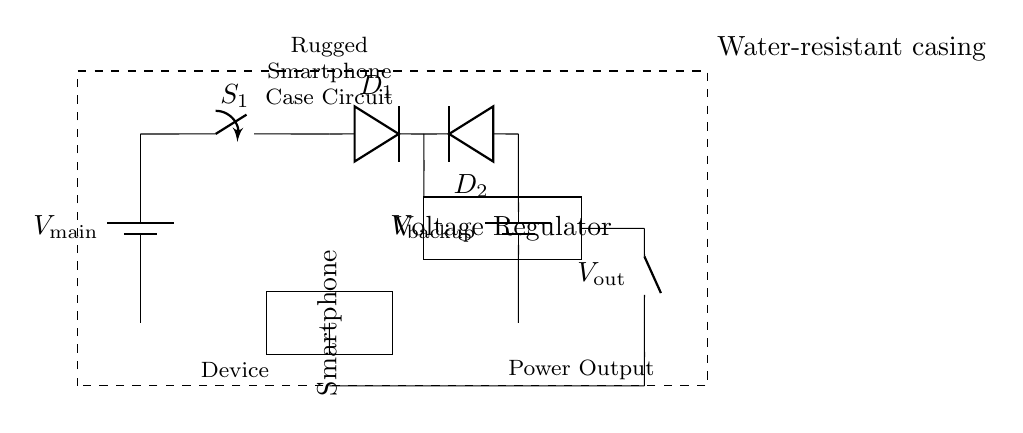What is the main power source in this circuit? The main power source is indicated by the battery labeled as V_main, which provides the primary voltage to the circuit.
Answer: V_main What component is used to control power flow from the main battery? The switch labeled S_1 is responsible for controlling the flow of electricity from the main battery to the rest of the circuit.
Answer: S_1 How many diodes are present in this circuit? There are two diodes in the circuit, labeled D_1 and D_2, which are used for directing current flow from their respective power sources.
Answer: 2 What is the purpose of the voltage regulator in the circuit? The voltage regulator, which is indicated by a rectangle in the diagram, ensures that the output voltage remains stable regardless of variations in the input voltage.
Answer: Stabilizes voltage What happens when the main battery is disconnected? If the main battery is disconnected, the backup battery (labeled V_backup) can still supply power to the circuit through diode D_2, ensuring continued operation.
Answer: Power from backup What element provides protection against water damage in this design? The circuit is enclosed in a dashed rectangle labeled as the water-resistant casing, which indicates that it is designed to protect the internal components from water.
Answer: Water-resistant casing What is the output designation of this circuit? The output of this circuit is labeled as V_out, indicating the voltage available for powering external devices or components.
Answer: V_out 